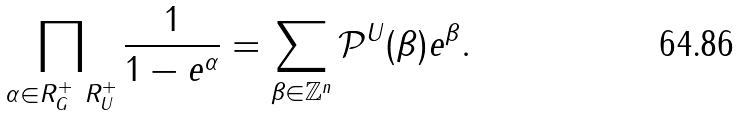<formula> <loc_0><loc_0><loc_500><loc_500>\prod _ { \alpha \in R _ { G } ^ { + } \ R _ { U } ^ { + } } \frac { 1 } { 1 - e ^ { \alpha } } = \sum _ { \beta \in \mathbb { Z } ^ { n } } \mathcal { P } ^ { U } ( \beta ) e ^ { \beta } .</formula> 